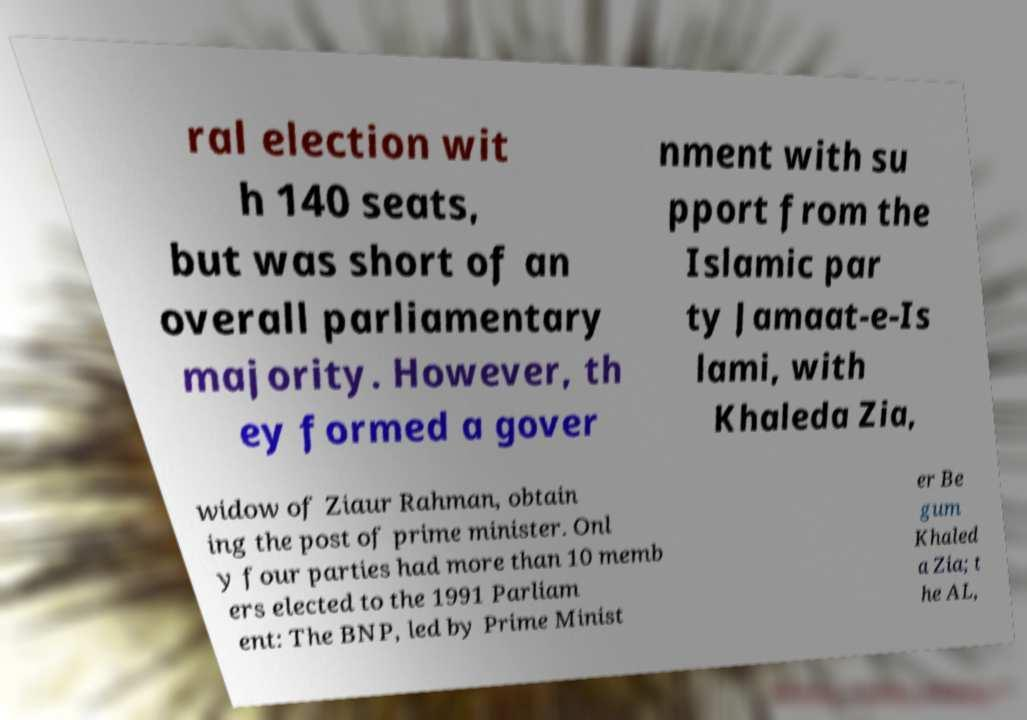Could you assist in decoding the text presented in this image and type it out clearly? ral election wit h 140 seats, but was short of an overall parliamentary majority. However, th ey formed a gover nment with su pport from the Islamic par ty Jamaat-e-Is lami, with Khaleda Zia, widow of Ziaur Rahman, obtain ing the post of prime minister. Onl y four parties had more than 10 memb ers elected to the 1991 Parliam ent: The BNP, led by Prime Minist er Be gum Khaled a Zia; t he AL, 